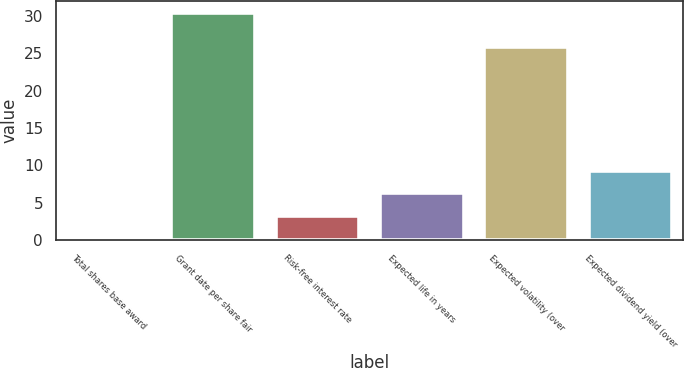<chart> <loc_0><loc_0><loc_500><loc_500><bar_chart><fcel>Total shares base award<fcel>Grant date per share fair<fcel>Risk-free interest rate<fcel>Expected life in years<fcel>Expected volatility (over<fcel>Expected dividend yield (over<nl><fcel>0.2<fcel>30.45<fcel>3.23<fcel>6.26<fcel>25.9<fcel>9.29<nl></chart> 